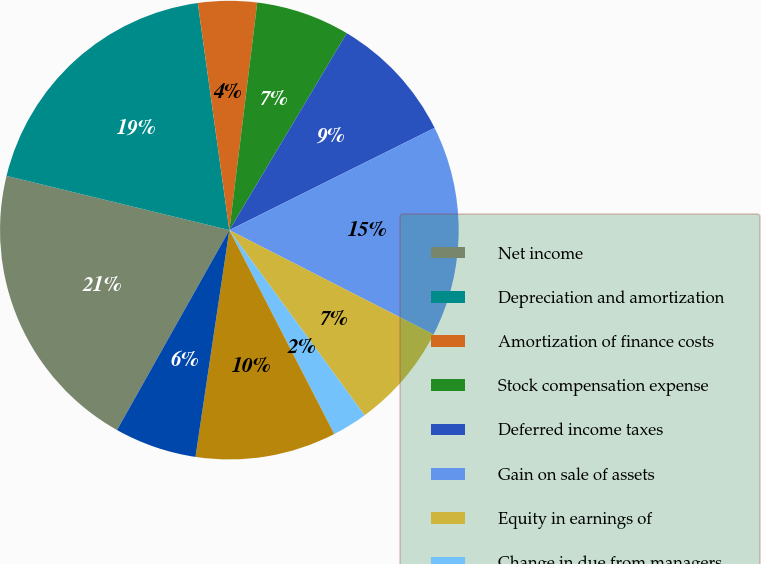<chart> <loc_0><loc_0><loc_500><loc_500><pie_chart><fcel>Net income<fcel>Depreciation and amortization<fcel>Amortization of finance costs<fcel>Stock compensation expense<fcel>Deferred income taxes<fcel>Gain on sale of assets<fcel>Equity in earnings of<fcel>Change in due from managers<fcel>Distributions from investments<fcel>Changes in other assets<nl><fcel>20.65%<fcel>19.0%<fcel>4.14%<fcel>6.61%<fcel>9.09%<fcel>14.87%<fcel>7.44%<fcel>2.48%<fcel>9.92%<fcel>5.79%<nl></chart> 